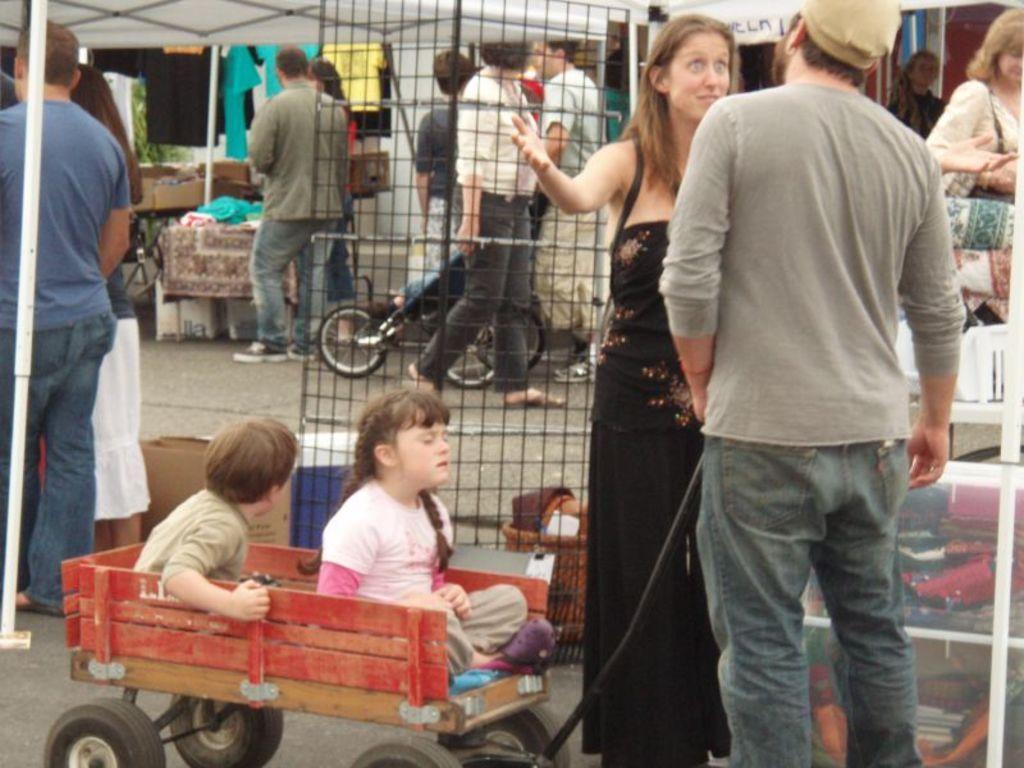How would you summarize this image in a sentence or two? In this image there is man standing towards the bottom of the image, he is holding an object, there is a woman standing towards the bottom of the image, there is a girl sitting, there is a boy sitting, there are objects towards the bottom of the image, there is road towards the bottom of the image, there are persons on the road, there is tent towards the top of the image, there is a metal rod towards the left of the image, there are clothes, there is a fence, there are objects on the road, there are objects towards the right of the image, there is a bicycle, there is a wall. 